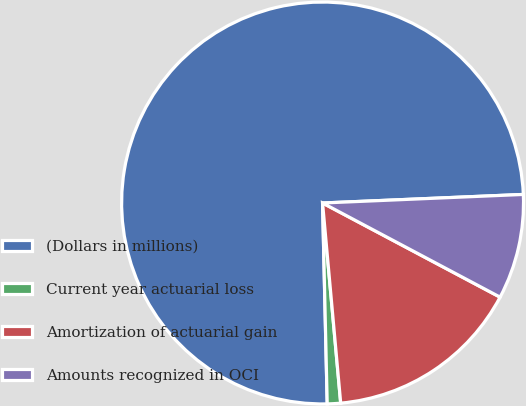Convert chart to OTSL. <chart><loc_0><loc_0><loc_500><loc_500><pie_chart><fcel>(Dollars in millions)<fcel>Current year actuarial loss<fcel>Amortization of actuarial gain<fcel>Amounts recognized in OCI<nl><fcel>74.69%<fcel>1.07%<fcel>15.8%<fcel>8.44%<nl></chart> 